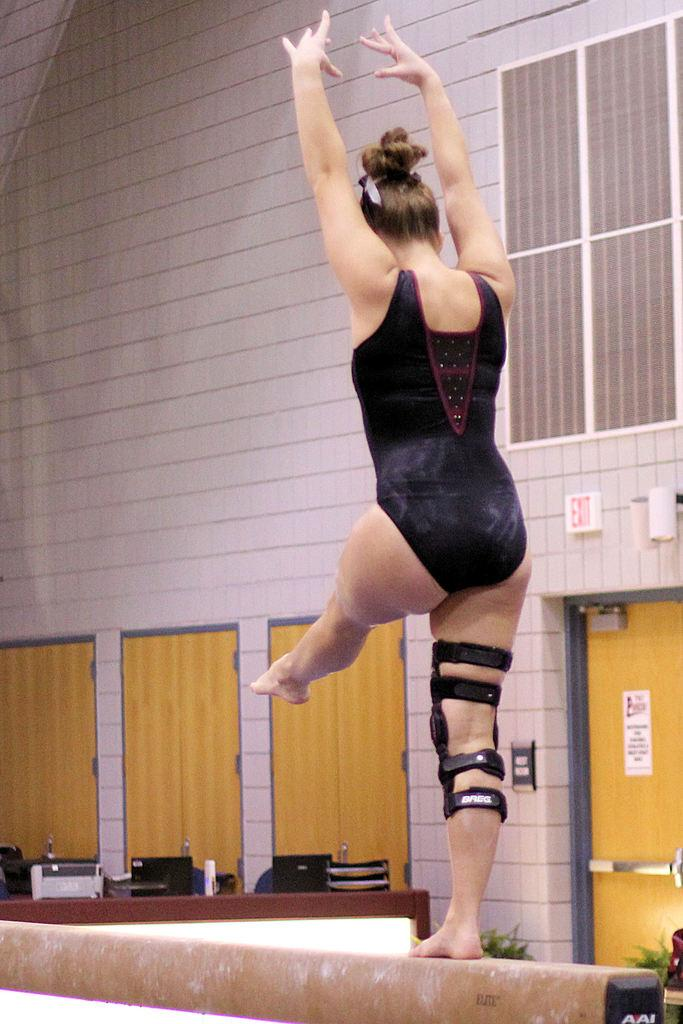What is present in the foreground of the image? There is a woman in the image. What can be seen in the background of the image? There is a wall, plants, and some objects visible in the background of the image. How many toes can be seen on the woman's feet in the image? The image does not show the woman's feet, so it is not possible to determine how many toes might be visible. 